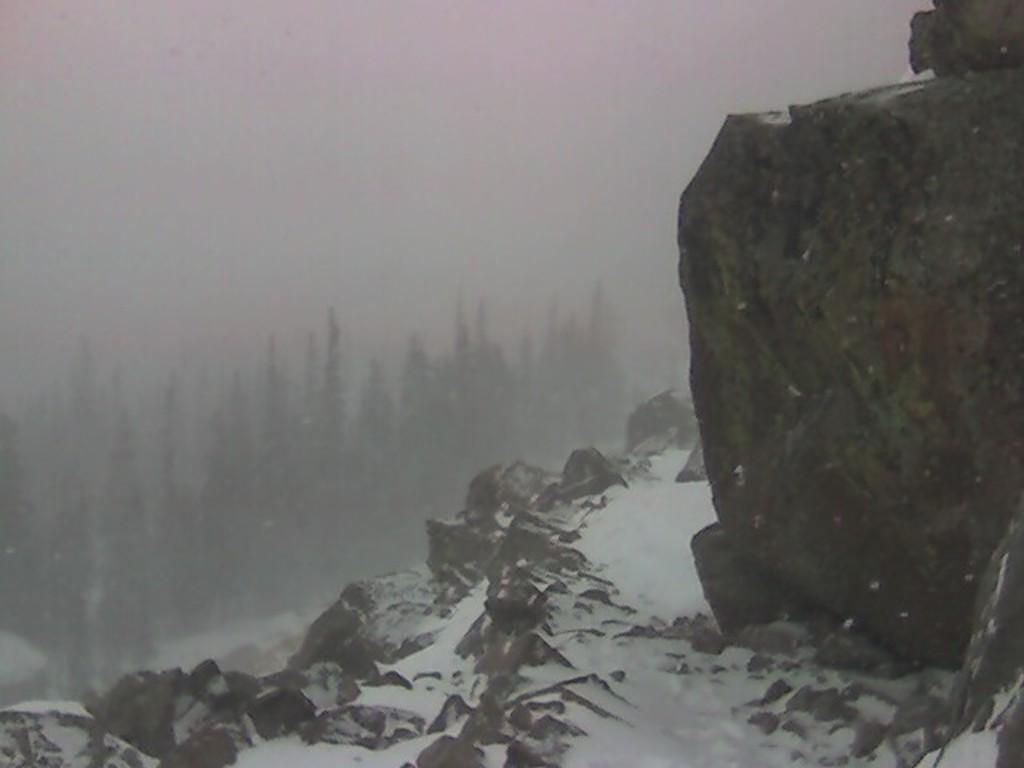What type of vegetation can be seen in the distance in the image? There are trees in the distance in the image. What is the weather condition in the image? There is snow visible in the image, indicating a cold or wintry condition. What type of thumb can be seen in the image? There is no thumb present in the image. What sign is visible in the image? There is no sign visible in the image. 